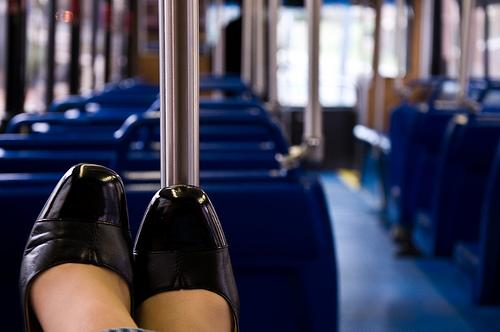What is the main mode of transportation depicted in the image? The main mode of transportation is a bus with blue seats and silver poles. Provide a brief description of the woman's shoes in the image. The woman is wearing shiny black flats with a reflective toe area. Provide a concise overview of the scene captured in the image. The image captures a bus interior with blue seats, people sitting and standing, silver poles, and a woman wearing shiny black flats. Mention the predominant colors in the image and how they are used. The predominant colors are blue for the bus seats, black for the woman's shoes, and silver for the poles. Describe the features of the bus and its environment. The bus has blue seats, tall silver poles, side windows, and a middle walkway, with a yellow line by the entrance. What does the woman do with her feet, and what can you see of her attire? The woman is resting her feet on the seat in front of her, wearing shiny black flats and revealing the bottom of her blue jeans. Describe the interaction between the people present in the image. A woman is resting her feet on the seat in front of her, while another person is sitting, and someone is standing near the window. Enumerate the visible parts of the woman's appearance. The top of the woman's feet, her reflective black shoes, and the bottom of her blue jeans are visible. What are the various uses of metal in the image? Metal is used for the poles on the bus, with one in front of the woman, and for the legs of the seats. Provide a creative description of the scene taking place in the image. Amidst the vibrant blue sea of bus seats, a woman's shiny black flats stand out like precious gems as she rests her feet on the seat before her. 